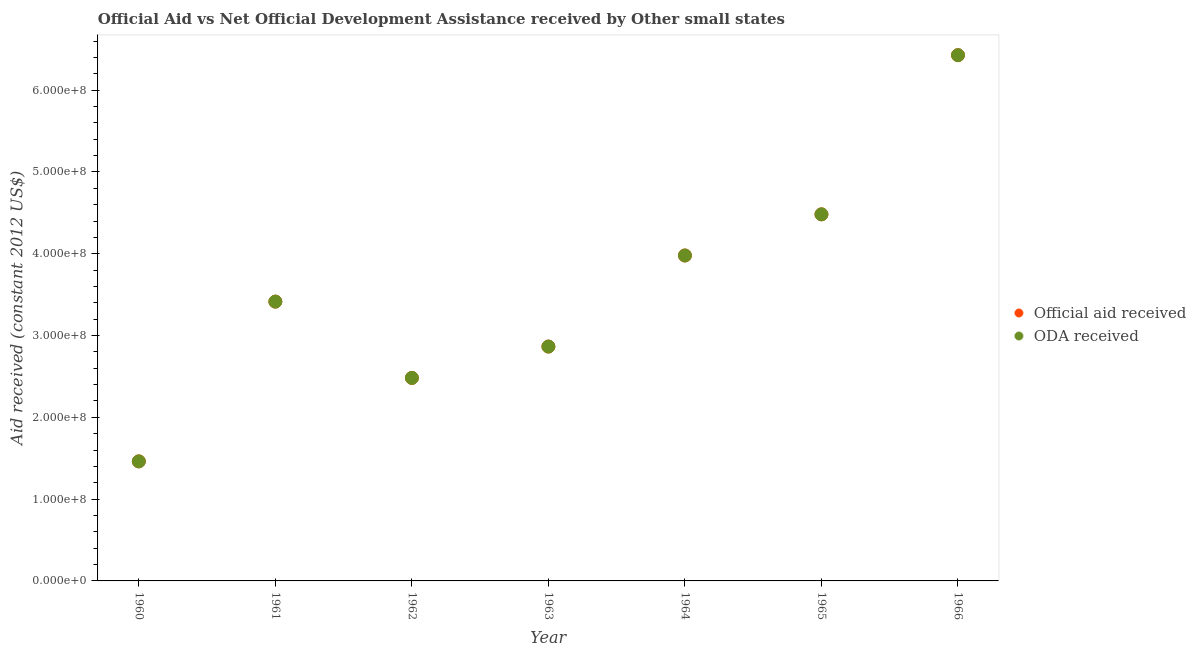How many different coloured dotlines are there?
Your answer should be very brief. 2. What is the oda received in 1966?
Your response must be concise. 6.43e+08. Across all years, what is the maximum official aid received?
Offer a very short reply. 6.43e+08. Across all years, what is the minimum oda received?
Provide a short and direct response. 1.46e+08. In which year was the official aid received maximum?
Offer a very short reply. 1966. What is the total official aid received in the graph?
Provide a succinct answer. 2.51e+09. What is the difference between the oda received in 1960 and that in 1966?
Offer a terse response. -4.97e+08. What is the difference between the official aid received in 1963 and the oda received in 1961?
Make the answer very short. -5.49e+07. What is the average oda received per year?
Make the answer very short. 3.59e+08. In the year 1964, what is the difference between the official aid received and oda received?
Make the answer very short. 0. In how many years, is the official aid received greater than 560000000 US$?
Your answer should be compact. 1. What is the ratio of the oda received in 1961 to that in 1964?
Give a very brief answer. 0.86. What is the difference between the highest and the second highest oda received?
Your response must be concise. 1.95e+08. What is the difference between the highest and the lowest oda received?
Keep it short and to the point. 4.97e+08. In how many years, is the official aid received greater than the average official aid received taken over all years?
Give a very brief answer. 3. Is the official aid received strictly greater than the oda received over the years?
Your response must be concise. No. Is the oda received strictly less than the official aid received over the years?
Offer a terse response. No. What is the difference between two consecutive major ticks on the Y-axis?
Offer a terse response. 1.00e+08. Are the values on the major ticks of Y-axis written in scientific E-notation?
Provide a succinct answer. Yes. Does the graph contain grids?
Offer a very short reply. No. Where does the legend appear in the graph?
Keep it short and to the point. Center right. How many legend labels are there?
Give a very brief answer. 2. How are the legend labels stacked?
Provide a succinct answer. Vertical. What is the title of the graph?
Provide a short and direct response. Official Aid vs Net Official Development Assistance received by Other small states . Does "Domestic Liabilities" appear as one of the legend labels in the graph?
Give a very brief answer. No. What is the label or title of the Y-axis?
Make the answer very short. Aid received (constant 2012 US$). What is the Aid received (constant 2012 US$) in Official aid received in 1960?
Make the answer very short. 1.46e+08. What is the Aid received (constant 2012 US$) of ODA received in 1960?
Offer a very short reply. 1.46e+08. What is the Aid received (constant 2012 US$) of Official aid received in 1961?
Ensure brevity in your answer.  3.41e+08. What is the Aid received (constant 2012 US$) of ODA received in 1961?
Your response must be concise. 3.41e+08. What is the Aid received (constant 2012 US$) of Official aid received in 1962?
Provide a succinct answer. 2.48e+08. What is the Aid received (constant 2012 US$) in ODA received in 1962?
Provide a short and direct response. 2.48e+08. What is the Aid received (constant 2012 US$) in Official aid received in 1963?
Your answer should be compact. 2.87e+08. What is the Aid received (constant 2012 US$) in ODA received in 1963?
Give a very brief answer. 2.87e+08. What is the Aid received (constant 2012 US$) of Official aid received in 1964?
Keep it short and to the point. 3.98e+08. What is the Aid received (constant 2012 US$) in ODA received in 1964?
Your response must be concise. 3.98e+08. What is the Aid received (constant 2012 US$) of Official aid received in 1965?
Offer a terse response. 4.48e+08. What is the Aid received (constant 2012 US$) of ODA received in 1965?
Your answer should be very brief. 4.48e+08. What is the Aid received (constant 2012 US$) in Official aid received in 1966?
Your answer should be compact. 6.43e+08. What is the Aid received (constant 2012 US$) in ODA received in 1966?
Offer a terse response. 6.43e+08. Across all years, what is the maximum Aid received (constant 2012 US$) in Official aid received?
Make the answer very short. 6.43e+08. Across all years, what is the maximum Aid received (constant 2012 US$) in ODA received?
Offer a terse response. 6.43e+08. Across all years, what is the minimum Aid received (constant 2012 US$) in Official aid received?
Ensure brevity in your answer.  1.46e+08. Across all years, what is the minimum Aid received (constant 2012 US$) in ODA received?
Provide a short and direct response. 1.46e+08. What is the total Aid received (constant 2012 US$) of Official aid received in the graph?
Your response must be concise. 2.51e+09. What is the total Aid received (constant 2012 US$) of ODA received in the graph?
Ensure brevity in your answer.  2.51e+09. What is the difference between the Aid received (constant 2012 US$) of Official aid received in 1960 and that in 1961?
Offer a very short reply. -1.95e+08. What is the difference between the Aid received (constant 2012 US$) in ODA received in 1960 and that in 1961?
Your answer should be compact. -1.95e+08. What is the difference between the Aid received (constant 2012 US$) of Official aid received in 1960 and that in 1962?
Provide a short and direct response. -1.02e+08. What is the difference between the Aid received (constant 2012 US$) of ODA received in 1960 and that in 1962?
Offer a very short reply. -1.02e+08. What is the difference between the Aid received (constant 2012 US$) in Official aid received in 1960 and that in 1963?
Your answer should be very brief. -1.40e+08. What is the difference between the Aid received (constant 2012 US$) of ODA received in 1960 and that in 1963?
Offer a terse response. -1.40e+08. What is the difference between the Aid received (constant 2012 US$) of Official aid received in 1960 and that in 1964?
Offer a terse response. -2.52e+08. What is the difference between the Aid received (constant 2012 US$) of ODA received in 1960 and that in 1964?
Your answer should be compact. -2.52e+08. What is the difference between the Aid received (constant 2012 US$) of Official aid received in 1960 and that in 1965?
Ensure brevity in your answer.  -3.02e+08. What is the difference between the Aid received (constant 2012 US$) in ODA received in 1960 and that in 1965?
Your answer should be compact. -3.02e+08. What is the difference between the Aid received (constant 2012 US$) of Official aid received in 1960 and that in 1966?
Your answer should be compact. -4.97e+08. What is the difference between the Aid received (constant 2012 US$) of ODA received in 1960 and that in 1966?
Your answer should be compact. -4.97e+08. What is the difference between the Aid received (constant 2012 US$) of Official aid received in 1961 and that in 1962?
Your answer should be compact. 9.32e+07. What is the difference between the Aid received (constant 2012 US$) in ODA received in 1961 and that in 1962?
Offer a very short reply. 9.32e+07. What is the difference between the Aid received (constant 2012 US$) of Official aid received in 1961 and that in 1963?
Provide a succinct answer. 5.49e+07. What is the difference between the Aid received (constant 2012 US$) of ODA received in 1961 and that in 1963?
Provide a short and direct response. 5.49e+07. What is the difference between the Aid received (constant 2012 US$) of Official aid received in 1961 and that in 1964?
Provide a short and direct response. -5.64e+07. What is the difference between the Aid received (constant 2012 US$) of ODA received in 1961 and that in 1964?
Provide a succinct answer. -5.64e+07. What is the difference between the Aid received (constant 2012 US$) of Official aid received in 1961 and that in 1965?
Offer a terse response. -1.07e+08. What is the difference between the Aid received (constant 2012 US$) of ODA received in 1961 and that in 1965?
Give a very brief answer. -1.07e+08. What is the difference between the Aid received (constant 2012 US$) of Official aid received in 1961 and that in 1966?
Your response must be concise. -3.01e+08. What is the difference between the Aid received (constant 2012 US$) in ODA received in 1961 and that in 1966?
Make the answer very short. -3.01e+08. What is the difference between the Aid received (constant 2012 US$) of Official aid received in 1962 and that in 1963?
Give a very brief answer. -3.83e+07. What is the difference between the Aid received (constant 2012 US$) of ODA received in 1962 and that in 1963?
Offer a terse response. -3.83e+07. What is the difference between the Aid received (constant 2012 US$) of Official aid received in 1962 and that in 1964?
Give a very brief answer. -1.50e+08. What is the difference between the Aid received (constant 2012 US$) in ODA received in 1962 and that in 1964?
Your answer should be very brief. -1.50e+08. What is the difference between the Aid received (constant 2012 US$) in Official aid received in 1962 and that in 1965?
Provide a succinct answer. -2.00e+08. What is the difference between the Aid received (constant 2012 US$) of ODA received in 1962 and that in 1965?
Offer a terse response. -2.00e+08. What is the difference between the Aid received (constant 2012 US$) in Official aid received in 1962 and that in 1966?
Offer a terse response. -3.95e+08. What is the difference between the Aid received (constant 2012 US$) in ODA received in 1962 and that in 1966?
Your response must be concise. -3.95e+08. What is the difference between the Aid received (constant 2012 US$) of Official aid received in 1963 and that in 1964?
Keep it short and to the point. -1.11e+08. What is the difference between the Aid received (constant 2012 US$) in ODA received in 1963 and that in 1964?
Keep it short and to the point. -1.11e+08. What is the difference between the Aid received (constant 2012 US$) in Official aid received in 1963 and that in 1965?
Provide a succinct answer. -1.62e+08. What is the difference between the Aid received (constant 2012 US$) of ODA received in 1963 and that in 1965?
Your answer should be very brief. -1.62e+08. What is the difference between the Aid received (constant 2012 US$) in Official aid received in 1963 and that in 1966?
Your answer should be very brief. -3.56e+08. What is the difference between the Aid received (constant 2012 US$) in ODA received in 1963 and that in 1966?
Provide a succinct answer. -3.56e+08. What is the difference between the Aid received (constant 2012 US$) of Official aid received in 1964 and that in 1965?
Provide a short and direct response. -5.03e+07. What is the difference between the Aid received (constant 2012 US$) in ODA received in 1964 and that in 1965?
Keep it short and to the point. -5.03e+07. What is the difference between the Aid received (constant 2012 US$) in Official aid received in 1964 and that in 1966?
Your answer should be very brief. -2.45e+08. What is the difference between the Aid received (constant 2012 US$) of ODA received in 1964 and that in 1966?
Provide a succinct answer. -2.45e+08. What is the difference between the Aid received (constant 2012 US$) of Official aid received in 1965 and that in 1966?
Keep it short and to the point. -1.95e+08. What is the difference between the Aid received (constant 2012 US$) of ODA received in 1965 and that in 1966?
Your answer should be very brief. -1.95e+08. What is the difference between the Aid received (constant 2012 US$) of Official aid received in 1960 and the Aid received (constant 2012 US$) of ODA received in 1961?
Your answer should be compact. -1.95e+08. What is the difference between the Aid received (constant 2012 US$) in Official aid received in 1960 and the Aid received (constant 2012 US$) in ODA received in 1962?
Offer a terse response. -1.02e+08. What is the difference between the Aid received (constant 2012 US$) of Official aid received in 1960 and the Aid received (constant 2012 US$) of ODA received in 1963?
Your answer should be very brief. -1.40e+08. What is the difference between the Aid received (constant 2012 US$) of Official aid received in 1960 and the Aid received (constant 2012 US$) of ODA received in 1964?
Give a very brief answer. -2.52e+08. What is the difference between the Aid received (constant 2012 US$) in Official aid received in 1960 and the Aid received (constant 2012 US$) in ODA received in 1965?
Give a very brief answer. -3.02e+08. What is the difference between the Aid received (constant 2012 US$) of Official aid received in 1960 and the Aid received (constant 2012 US$) of ODA received in 1966?
Ensure brevity in your answer.  -4.97e+08. What is the difference between the Aid received (constant 2012 US$) in Official aid received in 1961 and the Aid received (constant 2012 US$) in ODA received in 1962?
Provide a short and direct response. 9.32e+07. What is the difference between the Aid received (constant 2012 US$) in Official aid received in 1961 and the Aid received (constant 2012 US$) in ODA received in 1963?
Ensure brevity in your answer.  5.49e+07. What is the difference between the Aid received (constant 2012 US$) of Official aid received in 1961 and the Aid received (constant 2012 US$) of ODA received in 1964?
Your response must be concise. -5.64e+07. What is the difference between the Aid received (constant 2012 US$) in Official aid received in 1961 and the Aid received (constant 2012 US$) in ODA received in 1965?
Your response must be concise. -1.07e+08. What is the difference between the Aid received (constant 2012 US$) in Official aid received in 1961 and the Aid received (constant 2012 US$) in ODA received in 1966?
Keep it short and to the point. -3.01e+08. What is the difference between the Aid received (constant 2012 US$) in Official aid received in 1962 and the Aid received (constant 2012 US$) in ODA received in 1963?
Keep it short and to the point. -3.83e+07. What is the difference between the Aid received (constant 2012 US$) of Official aid received in 1962 and the Aid received (constant 2012 US$) of ODA received in 1964?
Your answer should be compact. -1.50e+08. What is the difference between the Aid received (constant 2012 US$) of Official aid received in 1962 and the Aid received (constant 2012 US$) of ODA received in 1965?
Provide a short and direct response. -2.00e+08. What is the difference between the Aid received (constant 2012 US$) in Official aid received in 1962 and the Aid received (constant 2012 US$) in ODA received in 1966?
Your answer should be compact. -3.95e+08. What is the difference between the Aid received (constant 2012 US$) of Official aid received in 1963 and the Aid received (constant 2012 US$) of ODA received in 1964?
Provide a short and direct response. -1.11e+08. What is the difference between the Aid received (constant 2012 US$) in Official aid received in 1963 and the Aid received (constant 2012 US$) in ODA received in 1965?
Offer a very short reply. -1.62e+08. What is the difference between the Aid received (constant 2012 US$) of Official aid received in 1963 and the Aid received (constant 2012 US$) of ODA received in 1966?
Your answer should be compact. -3.56e+08. What is the difference between the Aid received (constant 2012 US$) of Official aid received in 1964 and the Aid received (constant 2012 US$) of ODA received in 1965?
Your answer should be compact. -5.03e+07. What is the difference between the Aid received (constant 2012 US$) of Official aid received in 1964 and the Aid received (constant 2012 US$) of ODA received in 1966?
Your response must be concise. -2.45e+08. What is the difference between the Aid received (constant 2012 US$) in Official aid received in 1965 and the Aid received (constant 2012 US$) in ODA received in 1966?
Make the answer very short. -1.95e+08. What is the average Aid received (constant 2012 US$) in Official aid received per year?
Offer a very short reply. 3.59e+08. What is the average Aid received (constant 2012 US$) of ODA received per year?
Offer a very short reply. 3.59e+08. In the year 1960, what is the difference between the Aid received (constant 2012 US$) of Official aid received and Aid received (constant 2012 US$) of ODA received?
Offer a terse response. 0. In the year 1962, what is the difference between the Aid received (constant 2012 US$) in Official aid received and Aid received (constant 2012 US$) in ODA received?
Provide a short and direct response. 0. In the year 1963, what is the difference between the Aid received (constant 2012 US$) of Official aid received and Aid received (constant 2012 US$) of ODA received?
Provide a short and direct response. 0. In the year 1964, what is the difference between the Aid received (constant 2012 US$) of Official aid received and Aid received (constant 2012 US$) of ODA received?
Ensure brevity in your answer.  0. What is the ratio of the Aid received (constant 2012 US$) of Official aid received in 1960 to that in 1961?
Provide a short and direct response. 0.43. What is the ratio of the Aid received (constant 2012 US$) of ODA received in 1960 to that in 1961?
Your response must be concise. 0.43. What is the ratio of the Aid received (constant 2012 US$) in Official aid received in 1960 to that in 1962?
Make the answer very short. 0.59. What is the ratio of the Aid received (constant 2012 US$) of ODA received in 1960 to that in 1962?
Provide a short and direct response. 0.59. What is the ratio of the Aid received (constant 2012 US$) in Official aid received in 1960 to that in 1963?
Your response must be concise. 0.51. What is the ratio of the Aid received (constant 2012 US$) in ODA received in 1960 to that in 1963?
Keep it short and to the point. 0.51. What is the ratio of the Aid received (constant 2012 US$) in Official aid received in 1960 to that in 1964?
Your response must be concise. 0.37. What is the ratio of the Aid received (constant 2012 US$) in ODA received in 1960 to that in 1964?
Your answer should be very brief. 0.37. What is the ratio of the Aid received (constant 2012 US$) in Official aid received in 1960 to that in 1965?
Provide a succinct answer. 0.33. What is the ratio of the Aid received (constant 2012 US$) in ODA received in 1960 to that in 1965?
Your answer should be compact. 0.33. What is the ratio of the Aid received (constant 2012 US$) in Official aid received in 1960 to that in 1966?
Keep it short and to the point. 0.23. What is the ratio of the Aid received (constant 2012 US$) in ODA received in 1960 to that in 1966?
Ensure brevity in your answer.  0.23. What is the ratio of the Aid received (constant 2012 US$) in Official aid received in 1961 to that in 1962?
Your answer should be compact. 1.38. What is the ratio of the Aid received (constant 2012 US$) in ODA received in 1961 to that in 1962?
Your answer should be compact. 1.38. What is the ratio of the Aid received (constant 2012 US$) in Official aid received in 1961 to that in 1963?
Your answer should be very brief. 1.19. What is the ratio of the Aid received (constant 2012 US$) in ODA received in 1961 to that in 1963?
Ensure brevity in your answer.  1.19. What is the ratio of the Aid received (constant 2012 US$) in Official aid received in 1961 to that in 1964?
Your answer should be very brief. 0.86. What is the ratio of the Aid received (constant 2012 US$) in ODA received in 1961 to that in 1964?
Give a very brief answer. 0.86. What is the ratio of the Aid received (constant 2012 US$) of Official aid received in 1961 to that in 1965?
Your answer should be compact. 0.76. What is the ratio of the Aid received (constant 2012 US$) of ODA received in 1961 to that in 1965?
Ensure brevity in your answer.  0.76. What is the ratio of the Aid received (constant 2012 US$) of Official aid received in 1961 to that in 1966?
Provide a succinct answer. 0.53. What is the ratio of the Aid received (constant 2012 US$) in ODA received in 1961 to that in 1966?
Your answer should be very brief. 0.53. What is the ratio of the Aid received (constant 2012 US$) of Official aid received in 1962 to that in 1963?
Your answer should be very brief. 0.87. What is the ratio of the Aid received (constant 2012 US$) in ODA received in 1962 to that in 1963?
Make the answer very short. 0.87. What is the ratio of the Aid received (constant 2012 US$) of Official aid received in 1962 to that in 1964?
Your response must be concise. 0.62. What is the ratio of the Aid received (constant 2012 US$) in ODA received in 1962 to that in 1964?
Your answer should be compact. 0.62. What is the ratio of the Aid received (constant 2012 US$) in Official aid received in 1962 to that in 1965?
Offer a very short reply. 0.55. What is the ratio of the Aid received (constant 2012 US$) of ODA received in 1962 to that in 1965?
Your response must be concise. 0.55. What is the ratio of the Aid received (constant 2012 US$) of Official aid received in 1962 to that in 1966?
Provide a succinct answer. 0.39. What is the ratio of the Aid received (constant 2012 US$) of ODA received in 1962 to that in 1966?
Provide a succinct answer. 0.39. What is the ratio of the Aid received (constant 2012 US$) in Official aid received in 1963 to that in 1964?
Your response must be concise. 0.72. What is the ratio of the Aid received (constant 2012 US$) in ODA received in 1963 to that in 1964?
Make the answer very short. 0.72. What is the ratio of the Aid received (constant 2012 US$) in Official aid received in 1963 to that in 1965?
Make the answer very short. 0.64. What is the ratio of the Aid received (constant 2012 US$) in ODA received in 1963 to that in 1965?
Provide a short and direct response. 0.64. What is the ratio of the Aid received (constant 2012 US$) of Official aid received in 1963 to that in 1966?
Keep it short and to the point. 0.45. What is the ratio of the Aid received (constant 2012 US$) in ODA received in 1963 to that in 1966?
Keep it short and to the point. 0.45. What is the ratio of the Aid received (constant 2012 US$) of Official aid received in 1964 to that in 1965?
Your answer should be compact. 0.89. What is the ratio of the Aid received (constant 2012 US$) in ODA received in 1964 to that in 1965?
Provide a succinct answer. 0.89. What is the ratio of the Aid received (constant 2012 US$) in Official aid received in 1964 to that in 1966?
Ensure brevity in your answer.  0.62. What is the ratio of the Aid received (constant 2012 US$) in ODA received in 1964 to that in 1966?
Offer a very short reply. 0.62. What is the ratio of the Aid received (constant 2012 US$) in Official aid received in 1965 to that in 1966?
Your answer should be compact. 0.7. What is the ratio of the Aid received (constant 2012 US$) in ODA received in 1965 to that in 1966?
Ensure brevity in your answer.  0.7. What is the difference between the highest and the second highest Aid received (constant 2012 US$) of Official aid received?
Offer a very short reply. 1.95e+08. What is the difference between the highest and the second highest Aid received (constant 2012 US$) of ODA received?
Offer a terse response. 1.95e+08. What is the difference between the highest and the lowest Aid received (constant 2012 US$) of Official aid received?
Give a very brief answer. 4.97e+08. What is the difference between the highest and the lowest Aid received (constant 2012 US$) in ODA received?
Provide a succinct answer. 4.97e+08. 